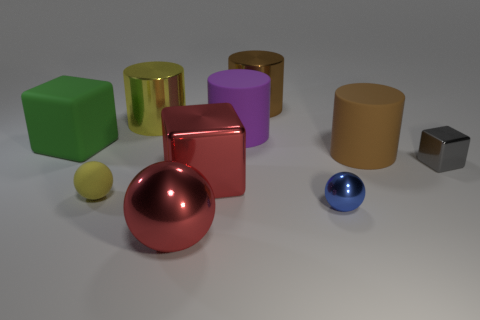How many other objects are the same color as the small metallic sphere?
Keep it short and to the point. 0. How many other things are there of the same size as the brown shiny cylinder?
Keep it short and to the point. 6. What number of things are things on the left side of the purple rubber cylinder or yellow metallic things left of the tiny metallic sphere?
Ensure brevity in your answer.  5. What number of other tiny metallic things have the same shape as the green thing?
Offer a very short reply. 1. There is a cube that is both left of the large purple rubber cylinder and right of the tiny yellow matte thing; what material is it?
Give a very brief answer. Metal. How many large cylinders are on the left side of the big red metal cube?
Provide a short and direct response. 1. How many small green objects are there?
Provide a short and direct response. 0. Do the yellow metallic cylinder and the purple rubber object have the same size?
Make the answer very short. Yes. Is there a purple rubber cylinder that is behind the brown object on the left side of the brown object on the right side of the brown shiny thing?
Ensure brevity in your answer.  No. What material is the tiny yellow object that is the same shape as the blue metallic thing?
Your answer should be compact. Rubber. 